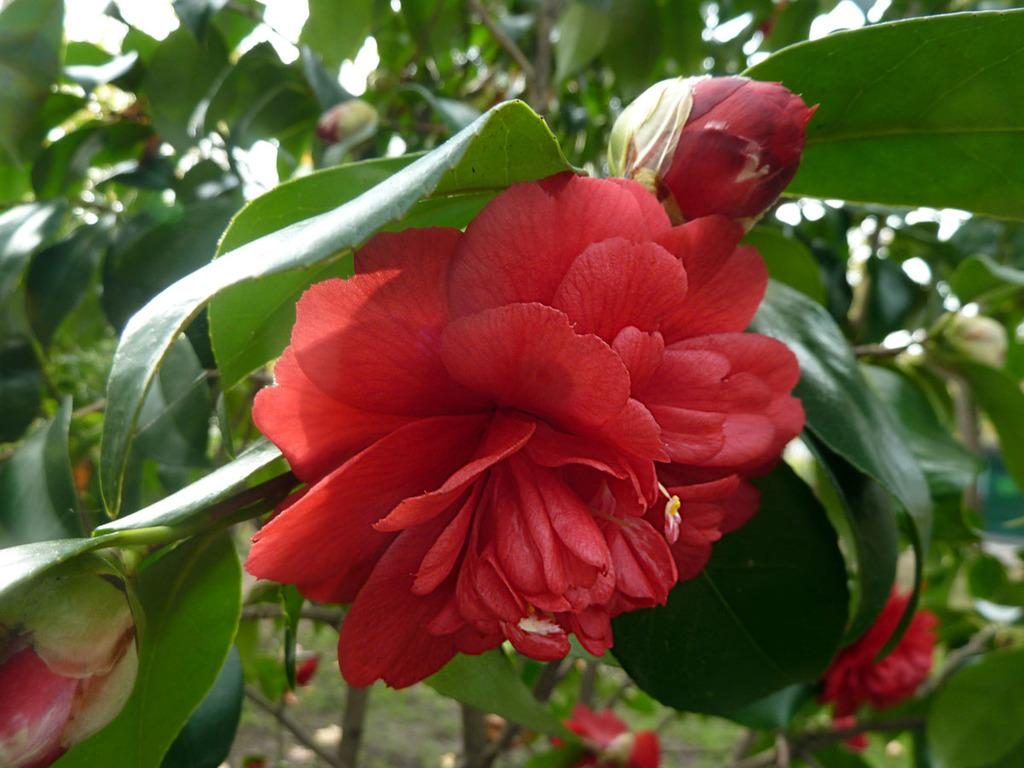What type of plant life can be seen in the image? There are leaves, buds, and flowers in the image. Can you describe the stage of growth for the plant life in the image? The image shows leaves, buds, and flowers, which suggests that the plants are in various stages of growth. What might be the purpose of the buds in the image? The buds in the image may be preparing to bloom into flowers. How does the hand in the image interact with the glue? There is no hand or glue present in the image; it only features plant life. 